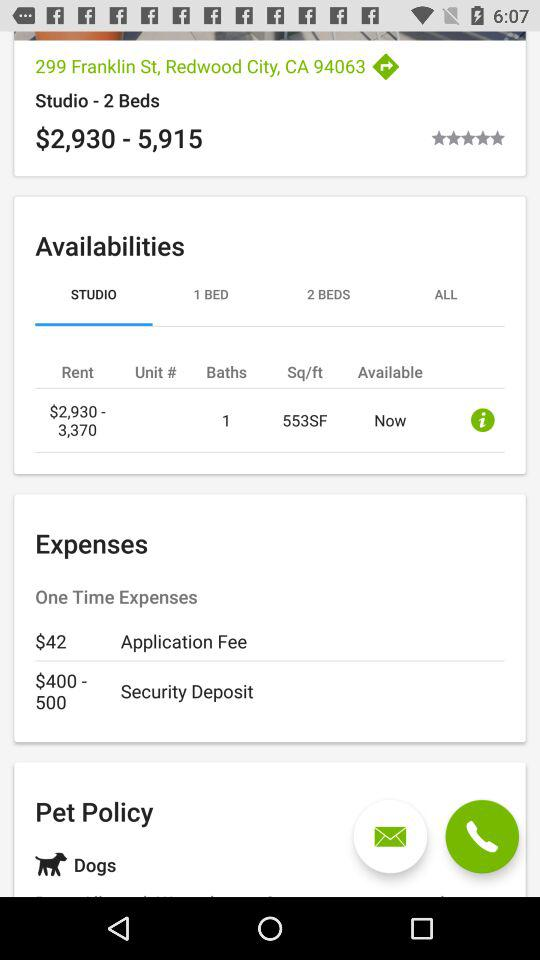What is the status of availabilities?
When the provided information is insufficient, respond with <no answer>. <no answer> 